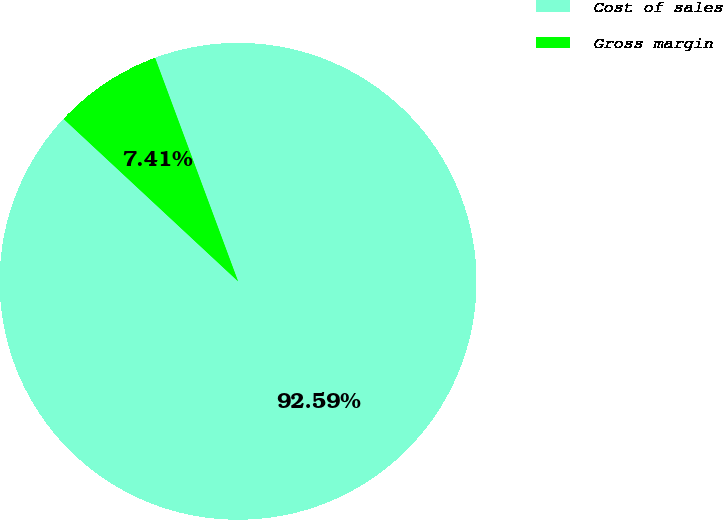Convert chart to OTSL. <chart><loc_0><loc_0><loc_500><loc_500><pie_chart><fcel>Cost of sales<fcel>Gross margin<nl><fcel>92.59%<fcel>7.41%<nl></chart> 